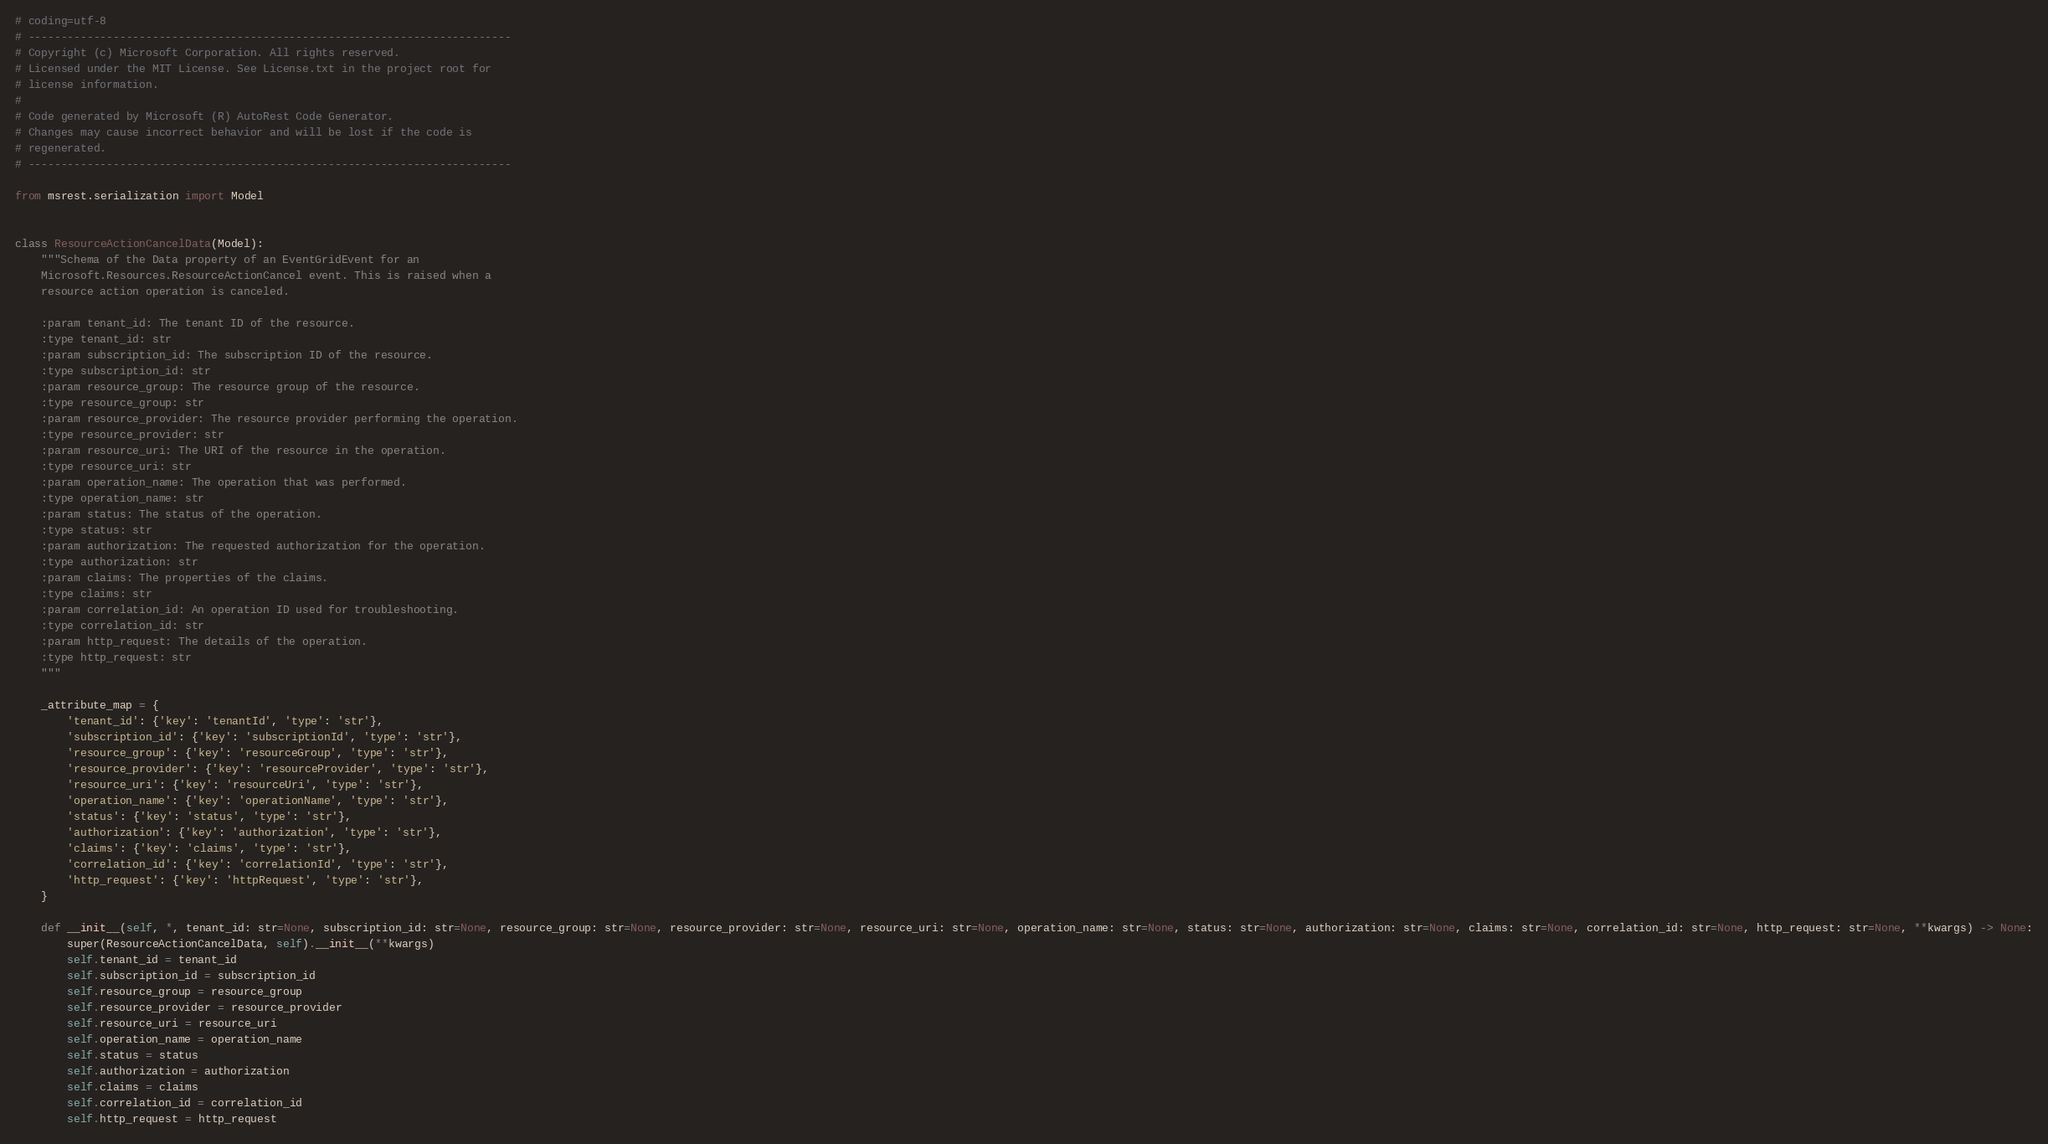Convert code to text. <code><loc_0><loc_0><loc_500><loc_500><_Python_># coding=utf-8
# --------------------------------------------------------------------------
# Copyright (c) Microsoft Corporation. All rights reserved.
# Licensed under the MIT License. See License.txt in the project root for
# license information.
#
# Code generated by Microsoft (R) AutoRest Code Generator.
# Changes may cause incorrect behavior and will be lost if the code is
# regenerated.
# --------------------------------------------------------------------------

from msrest.serialization import Model


class ResourceActionCancelData(Model):
    """Schema of the Data property of an EventGridEvent for an
    Microsoft.Resources.ResourceActionCancel event. This is raised when a
    resource action operation is canceled.

    :param tenant_id: The tenant ID of the resource.
    :type tenant_id: str
    :param subscription_id: The subscription ID of the resource.
    :type subscription_id: str
    :param resource_group: The resource group of the resource.
    :type resource_group: str
    :param resource_provider: The resource provider performing the operation.
    :type resource_provider: str
    :param resource_uri: The URI of the resource in the operation.
    :type resource_uri: str
    :param operation_name: The operation that was performed.
    :type operation_name: str
    :param status: The status of the operation.
    :type status: str
    :param authorization: The requested authorization for the operation.
    :type authorization: str
    :param claims: The properties of the claims.
    :type claims: str
    :param correlation_id: An operation ID used for troubleshooting.
    :type correlation_id: str
    :param http_request: The details of the operation.
    :type http_request: str
    """

    _attribute_map = {
        'tenant_id': {'key': 'tenantId', 'type': 'str'},
        'subscription_id': {'key': 'subscriptionId', 'type': 'str'},
        'resource_group': {'key': 'resourceGroup', 'type': 'str'},
        'resource_provider': {'key': 'resourceProvider', 'type': 'str'},
        'resource_uri': {'key': 'resourceUri', 'type': 'str'},
        'operation_name': {'key': 'operationName', 'type': 'str'},
        'status': {'key': 'status', 'type': 'str'},
        'authorization': {'key': 'authorization', 'type': 'str'},
        'claims': {'key': 'claims', 'type': 'str'},
        'correlation_id': {'key': 'correlationId', 'type': 'str'},
        'http_request': {'key': 'httpRequest', 'type': 'str'},
    }

    def __init__(self, *, tenant_id: str=None, subscription_id: str=None, resource_group: str=None, resource_provider: str=None, resource_uri: str=None, operation_name: str=None, status: str=None, authorization: str=None, claims: str=None, correlation_id: str=None, http_request: str=None, **kwargs) -> None:
        super(ResourceActionCancelData, self).__init__(**kwargs)
        self.tenant_id = tenant_id
        self.subscription_id = subscription_id
        self.resource_group = resource_group
        self.resource_provider = resource_provider
        self.resource_uri = resource_uri
        self.operation_name = operation_name
        self.status = status
        self.authorization = authorization
        self.claims = claims
        self.correlation_id = correlation_id
        self.http_request = http_request
</code> 